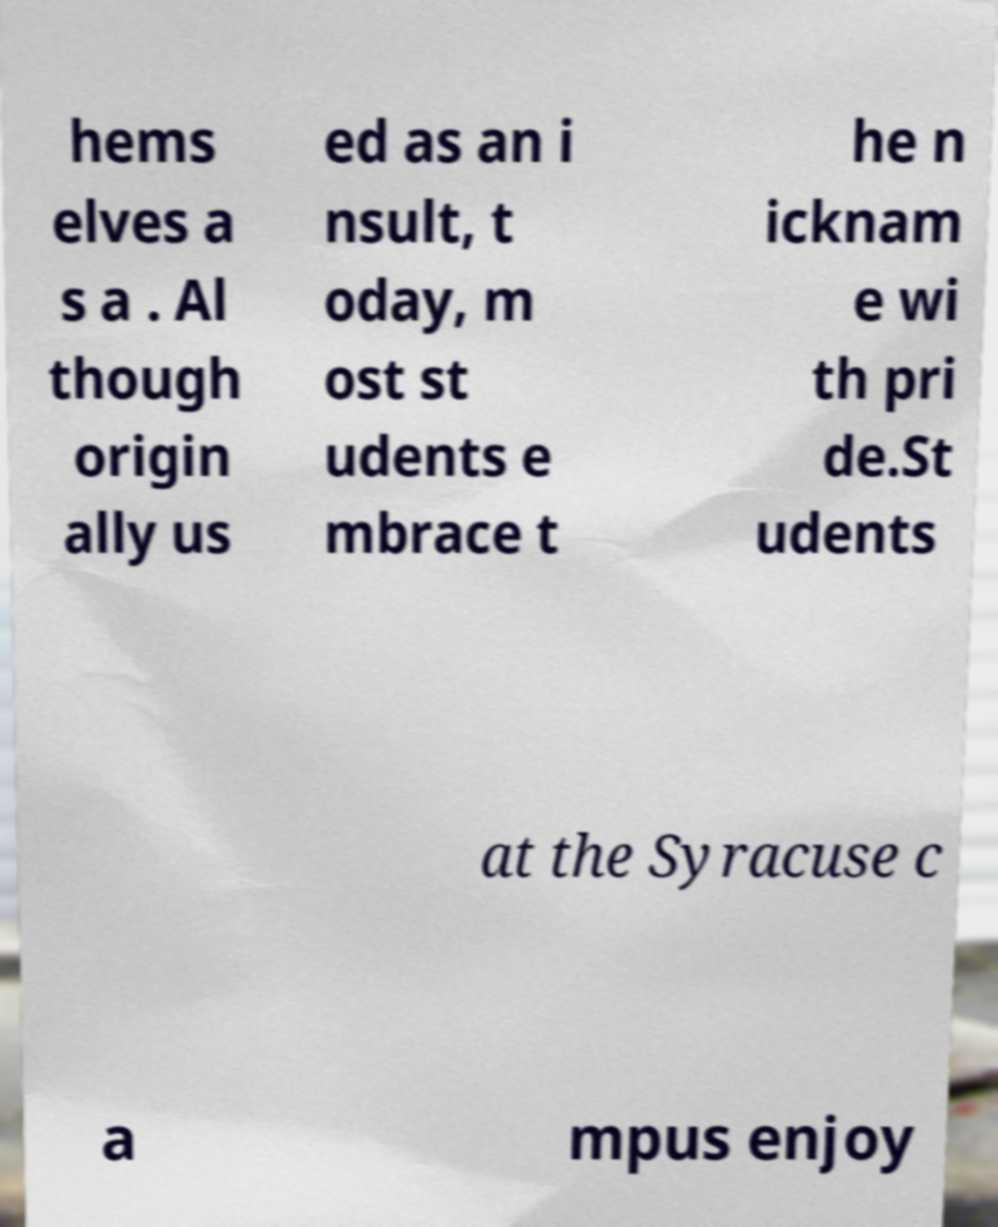I need the written content from this picture converted into text. Can you do that? hems elves a s a . Al though origin ally us ed as an i nsult, t oday, m ost st udents e mbrace t he n icknam e wi th pri de.St udents at the Syracuse c a mpus enjoy 